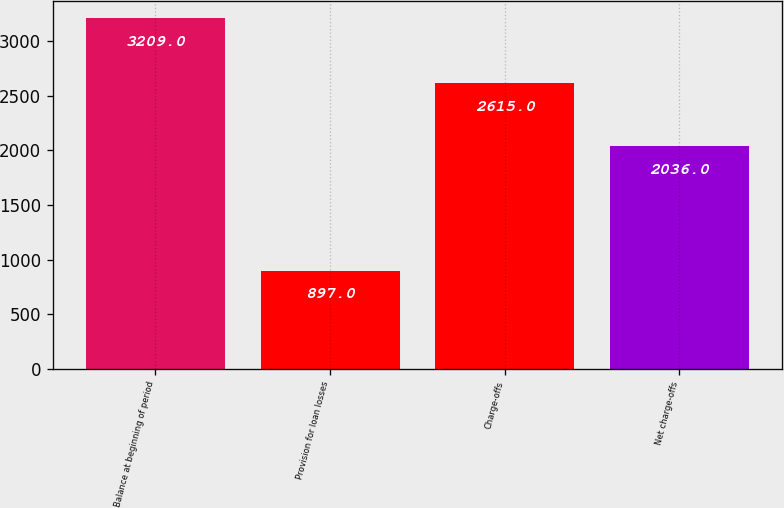<chart> <loc_0><loc_0><loc_500><loc_500><bar_chart><fcel>Balance at beginning of period<fcel>Provision for loan losses<fcel>Charge-offs<fcel>Net charge-offs<nl><fcel>3209<fcel>897<fcel>2615<fcel>2036<nl></chart> 